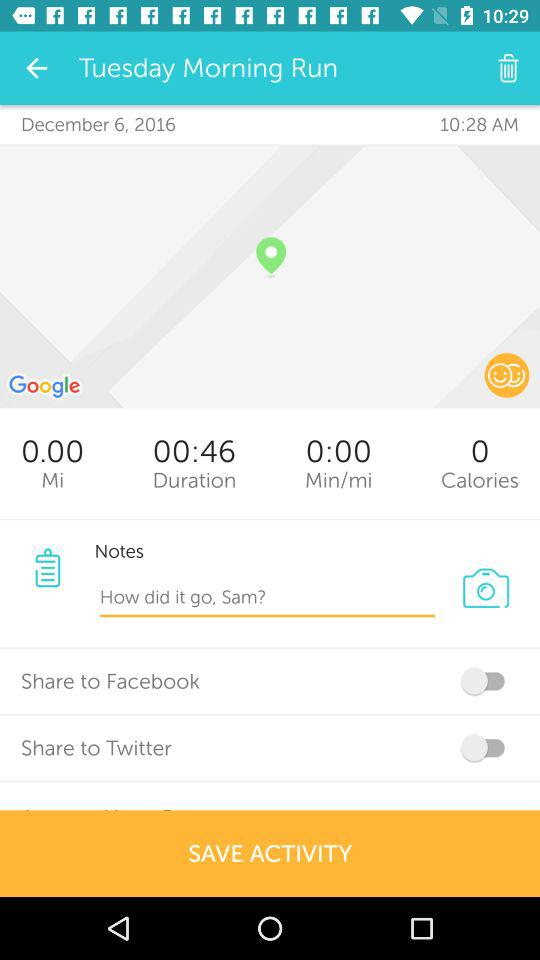What is the date on Tuesday? The date on Tuesday is December 6, 2016. 